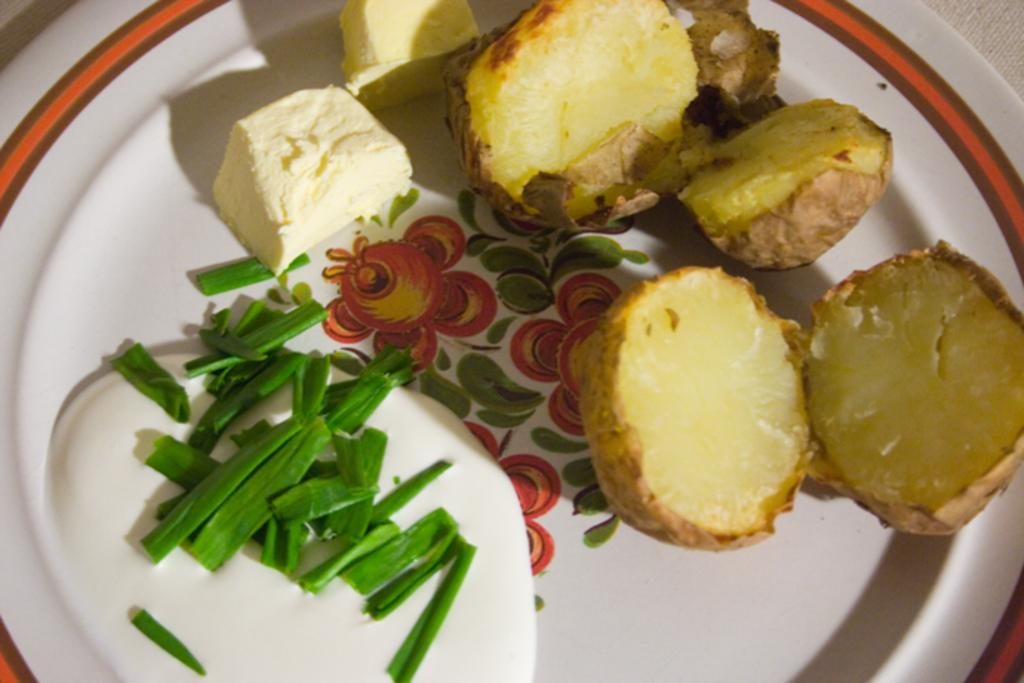What is on the plate that is visible in the image? There are baked potatoes on the plate. What accompanies the baked potatoes on the plate? There is butter, spring onions, and sauce on the plate. What type of surprise can be seen on the plate in the image? There is no surprise present on the plate in the image; it contains baked potatoes, butter, spring onions, and sauce. 